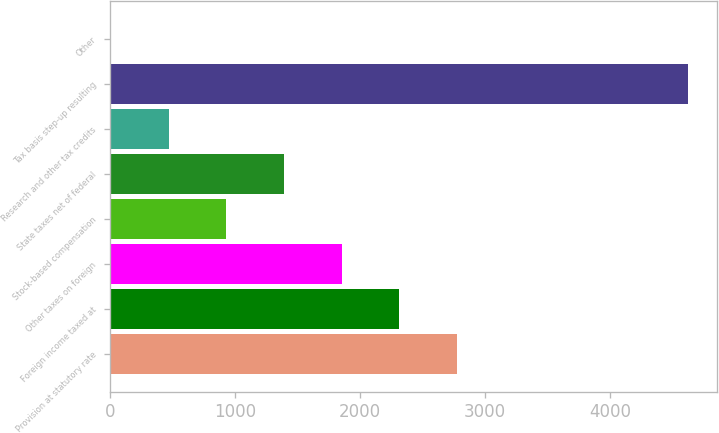Convert chart to OTSL. <chart><loc_0><loc_0><loc_500><loc_500><bar_chart><fcel>Provision at statutory rate<fcel>Foreign income taxed at<fcel>Other taxes on foreign<fcel>Stock-based compensation<fcel>State taxes net of federal<fcel>Research and other tax credits<fcel>Tax basis step-up resulting<fcel>Other<nl><fcel>2775.8<fcel>2314.5<fcel>1853.2<fcel>930.6<fcel>1391.9<fcel>469.3<fcel>4621<fcel>8<nl></chart> 